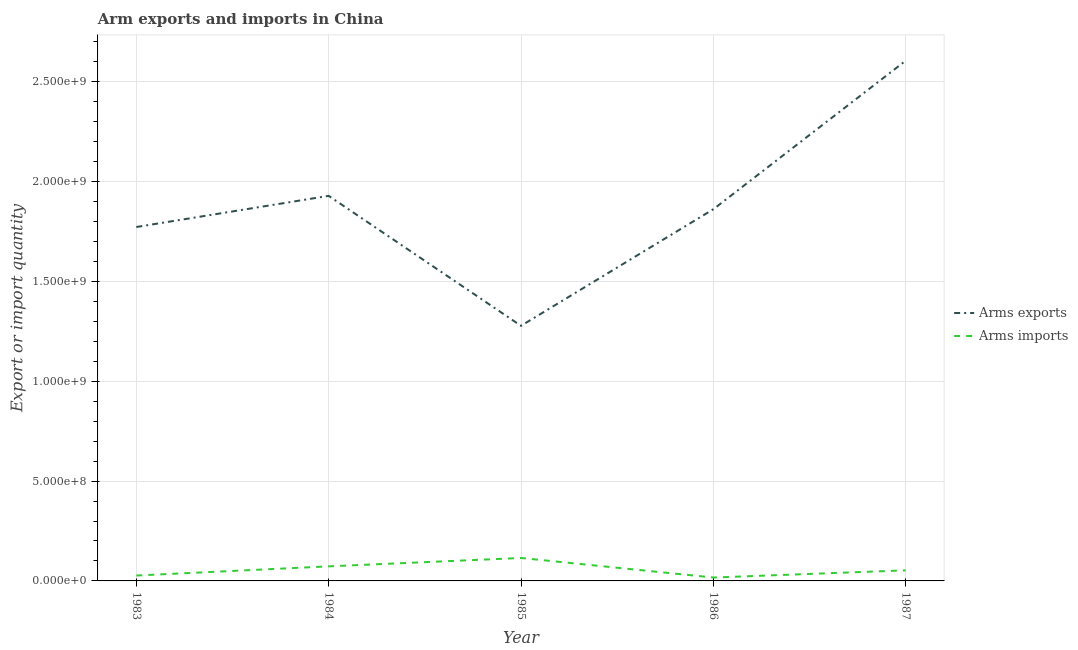Does the line corresponding to arms imports intersect with the line corresponding to arms exports?
Keep it short and to the point. No. Is the number of lines equal to the number of legend labels?
Provide a short and direct response. Yes. What is the arms imports in 1983?
Give a very brief answer. 2.70e+07. Across all years, what is the maximum arms imports?
Offer a very short reply. 1.15e+08. Across all years, what is the minimum arms exports?
Ensure brevity in your answer.  1.28e+09. In which year was the arms exports maximum?
Your answer should be very brief. 1987. What is the total arms imports in the graph?
Your response must be concise. 2.85e+08. What is the difference between the arms exports in 1983 and that in 1986?
Keep it short and to the point. -8.90e+07. What is the difference between the arms exports in 1986 and the arms imports in 1983?
Give a very brief answer. 1.84e+09. What is the average arms exports per year?
Provide a short and direct response. 1.89e+09. In the year 1984, what is the difference between the arms imports and arms exports?
Keep it short and to the point. -1.86e+09. What is the ratio of the arms imports in 1985 to that in 1987?
Provide a short and direct response. 2.17. What is the difference between the highest and the second highest arms imports?
Offer a very short reply. 4.20e+07. What is the difference between the highest and the lowest arms exports?
Give a very brief answer. 1.33e+09. In how many years, is the arms exports greater than the average arms exports taken over all years?
Offer a terse response. 2. Is the sum of the arms exports in 1983 and 1984 greater than the maximum arms imports across all years?
Provide a succinct answer. Yes. Is the arms exports strictly less than the arms imports over the years?
Keep it short and to the point. No. How many lines are there?
Your answer should be compact. 2. How many years are there in the graph?
Give a very brief answer. 5. Does the graph contain any zero values?
Offer a very short reply. No. Does the graph contain grids?
Provide a short and direct response. Yes. Where does the legend appear in the graph?
Offer a very short reply. Center right. What is the title of the graph?
Give a very brief answer. Arm exports and imports in China. Does "Highest 10% of population" appear as one of the legend labels in the graph?
Give a very brief answer. No. What is the label or title of the X-axis?
Give a very brief answer. Year. What is the label or title of the Y-axis?
Your response must be concise. Export or import quantity. What is the Export or import quantity of Arms exports in 1983?
Offer a very short reply. 1.77e+09. What is the Export or import quantity in Arms imports in 1983?
Make the answer very short. 2.70e+07. What is the Export or import quantity of Arms exports in 1984?
Give a very brief answer. 1.93e+09. What is the Export or import quantity in Arms imports in 1984?
Offer a terse response. 7.30e+07. What is the Export or import quantity of Arms exports in 1985?
Offer a very short reply. 1.28e+09. What is the Export or import quantity in Arms imports in 1985?
Your answer should be very brief. 1.15e+08. What is the Export or import quantity of Arms exports in 1986?
Make the answer very short. 1.86e+09. What is the Export or import quantity in Arms imports in 1986?
Your response must be concise. 1.70e+07. What is the Export or import quantity in Arms exports in 1987?
Make the answer very short. 2.61e+09. What is the Export or import quantity in Arms imports in 1987?
Provide a short and direct response. 5.30e+07. Across all years, what is the maximum Export or import quantity in Arms exports?
Provide a succinct answer. 2.61e+09. Across all years, what is the maximum Export or import quantity in Arms imports?
Keep it short and to the point. 1.15e+08. Across all years, what is the minimum Export or import quantity of Arms exports?
Give a very brief answer. 1.28e+09. Across all years, what is the minimum Export or import quantity in Arms imports?
Provide a short and direct response. 1.70e+07. What is the total Export or import quantity in Arms exports in the graph?
Your answer should be very brief. 9.45e+09. What is the total Export or import quantity of Arms imports in the graph?
Make the answer very short. 2.85e+08. What is the difference between the Export or import quantity of Arms exports in 1983 and that in 1984?
Your answer should be very brief. -1.56e+08. What is the difference between the Export or import quantity of Arms imports in 1983 and that in 1984?
Your answer should be compact. -4.60e+07. What is the difference between the Export or import quantity in Arms exports in 1983 and that in 1985?
Give a very brief answer. 4.95e+08. What is the difference between the Export or import quantity in Arms imports in 1983 and that in 1985?
Make the answer very short. -8.80e+07. What is the difference between the Export or import quantity of Arms exports in 1983 and that in 1986?
Your response must be concise. -8.90e+07. What is the difference between the Export or import quantity in Arms exports in 1983 and that in 1987?
Provide a succinct answer. -8.33e+08. What is the difference between the Export or import quantity in Arms imports in 1983 and that in 1987?
Ensure brevity in your answer.  -2.60e+07. What is the difference between the Export or import quantity in Arms exports in 1984 and that in 1985?
Provide a succinct answer. 6.51e+08. What is the difference between the Export or import quantity in Arms imports in 1984 and that in 1985?
Provide a short and direct response. -4.20e+07. What is the difference between the Export or import quantity of Arms exports in 1984 and that in 1986?
Your response must be concise. 6.70e+07. What is the difference between the Export or import quantity of Arms imports in 1984 and that in 1986?
Keep it short and to the point. 5.60e+07. What is the difference between the Export or import quantity of Arms exports in 1984 and that in 1987?
Offer a terse response. -6.77e+08. What is the difference between the Export or import quantity in Arms exports in 1985 and that in 1986?
Offer a terse response. -5.84e+08. What is the difference between the Export or import quantity in Arms imports in 1985 and that in 1986?
Give a very brief answer. 9.80e+07. What is the difference between the Export or import quantity in Arms exports in 1985 and that in 1987?
Offer a very short reply. -1.33e+09. What is the difference between the Export or import quantity in Arms imports in 1985 and that in 1987?
Your response must be concise. 6.20e+07. What is the difference between the Export or import quantity in Arms exports in 1986 and that in 1987?
Your response must be concise. -7.44e+08. What is the difference between the Export or import quantity of Arms imports in 1986 and that in 1987?
Offer a terse response. -3.60e+07. What is the difference between the Export or import quantity in Arms exports in 1983 and the Export or import quantity in Arms imports in 1984?
Give a very brief answer. 1.70e+09. What is the difference between the Export or import quantity in Arms exports in 1983 and the Export or import quantity in Arms imports in 1985?
Offer a very short reply. 1.66e+09. What is the difference between the Export or import quantity in Arms exports in 1983 and the Export or import quantity in Arms imports in 1986?
Your answer should be compact. 1.76e+09. What is the difference between the Export or import quantity in Arms exports in 1983 and the Export or import quantity in Arms imports in 1987?
Your answer should be compact. 1.72e+09. What is the difference between the Export or import quantity in Arms exports in 1984 and the Export or import quantity in Arms imports in 1985?
Your response must be concise. 1.81e+09. What is the difference between the Export or import quantity of Arms exports in 1984 and the Export or import quantity of Arms imports in 1986?
Offer a very short reply. 1.91e+09. What is the difference between the Export or import quantity of Arms exports in 1984 and the Export or import quantity of Arms imports in 1987?
Make the answer very short. 1.88e+09. What is the difference between the Export or import quantity of Arms exports in 1985 and the Export or import quantity of Arms imports in 1986?
Your response must be concise. 1.26e+09. What is the difference between the Export or import quantity in Arms exports in 1985 and the Export or import quantity in Arms imports in 1987?
Keep it short and to the point. 1.22e+09. What is the difference between the Export or import quantity in Arms exports in 1986 and the Export or import quantity in Arms imports in 1987?
Give a very brief answer. 1.81e+09. What is the average Export or import quantity in Arms exports per year?
Ensure brevity in your answer.  1.89e+09. What is the average Export or import quantity of Arms imports per year?
Offer a very short reply. 5.70e+07. In the year 1983, what is the difference between the Export or import quantity of Arms exports and Export or import quantity of Arms imports?
Provide a short and direct response. 1.75e+09. In the year 1984, what is the difference between the Export or import quantity in Arms exports and Export or import quantity in Arms imports?
Offer a very short reply. 1.86e+09. In the year 1985, what is the difference between the Export or import quantity in Arms exports and Export or import quantity in Arms imports?
Your answer should be very brief. 1.16e+09. In the year 1986, what is the difference between the Export or import quantity of Arms exports and Export or import quantity of Arms imports?
Offer a terse response. 1.84e+09. In the year 1987, what is the difference between the Export or import quantity in Arms exports and Export or import quantity in Arms imports?
Offer a terse response. 2.55e+09. What is the ratio of the Export or import quantity of Arms exports in 1983 to that in 1984?
Offer a terse response. 0.92. What is the ratio of the Export or import quantity of Arms imports in 1983 to that in 1984?
Offer a terse response. 0.37. What is the ratio of the Export or import quantity of Arms exports in 1983 to that in 1985?
Keep it short and to the point. 1.39. What is the ratio of the Export or import quantity of Arms imports in 1983 to that in 1985?
Offer a very short reply. 0.23. What is the ratio of the Export or import quantity in Arms exports in 1983 to that in 1986?
Your answer should be very brief. 0.95. What is the ratio of the Export or import quantity in Arms imports in 1983 to that in 1986?
Give a very brief answer. 1.59. What is the ratio of the Export or import quantity of Arms exports in 1983 to that in 1987?
Keep it short and to the point. 0.68. What is the ratio of the Export or import quantity of Arms imports in 1983 to that in 1987?
Provide a short and direct response. 0.51. What is the ratio of the Export or import quantity in Arms exports in 1984 to that in 1985?
Your response must be concise. 1.51. What is the ratio of the Export or import quantity of Arms imports in 1984 to that in 1985?
Your response must be concise. 0.63. What is the ratio of the Export or import quantity of Arms exports in 1984 to that in 1986?
Your answer should be very brief. 1.04. What is the ratio of the Export or import quantity in Arms imports in 1984 to that in 1986?
Your answer should be very brief. 4.29. What is the ratio of the Export or import quantity of Arms exports in 1984 to that in 1987?
Give a very brief answer. 0.74. What is the ratio of the Export or import quantity of Arms imports in 1984 to that in 1987?
Your answer should be very brief. 1.38. What is the ratio of the Export or import quantity in Arms exports in 1985 to that in 1986?
Provide a short and direct response. 0.69. What is the ratio of the Export or import quantity in Arms imports in 1985 to that in 1986?
Keep it short and to the point. 6.76. What is the ratio of the Export or import quantity of Arms exports in 1985 to that in 1987?
Your answer should be very brief. 0.49. What is the ratio of the Export or import quantity in Arms imports in 1985 to that in 1987?
Offer a very short reply. 2.17. What is the ratio of the Export or import quantity of Arms exports in 1986 to that in 1987?
Your answer should be compact. 0.71. What is the ratio of the Export or import quantity of Arms imports in 1986 to that in 1987?
Give a very brief answer. 0.32. What is the difference between the highest and the second highest Export or import quantity of Arms exports?
Keep it short and to the point. 6.77e+08. What is the difference between the highest and the second highest Export or import quantity of Arms imports?
Your response must be concise. 4.20e+07. What is the difference between the highest and the lowest Export or import quantity in Arms exports?
Give a very brief answer. 1.33e+09. What is the difference between the highest and the lowest Export or import quantity in Arms imports?
Your answer should be compact. 9.80e+07. 